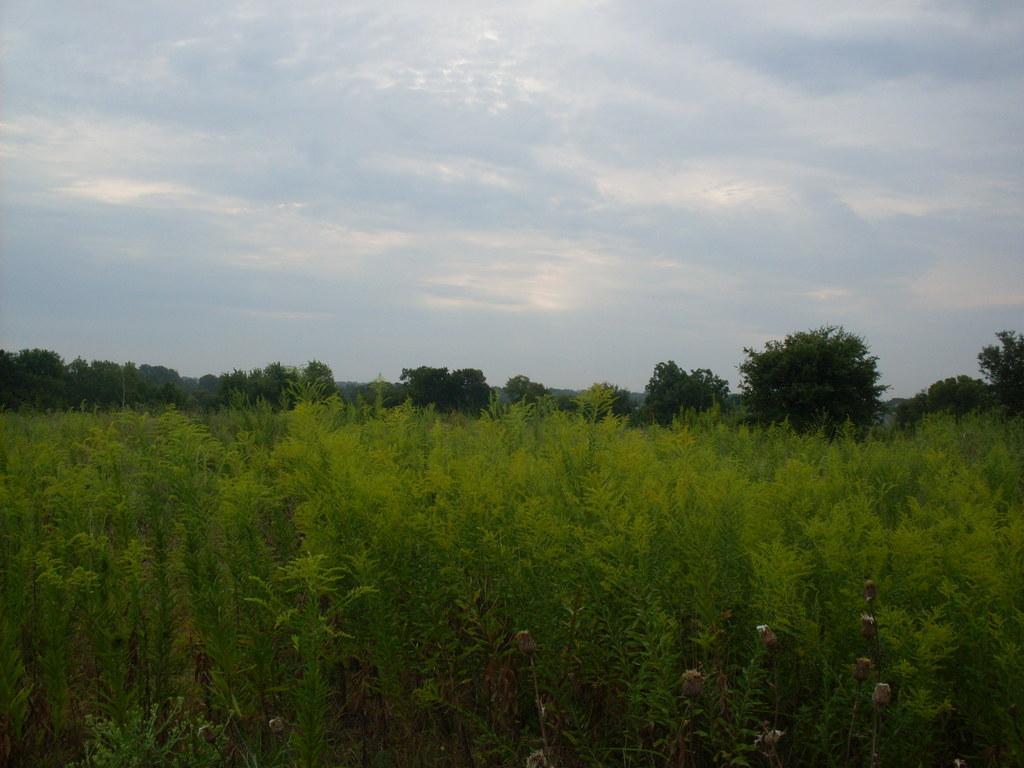Please provide a concise description of this image. Here we can see plants and trees. In the background there is sky. 